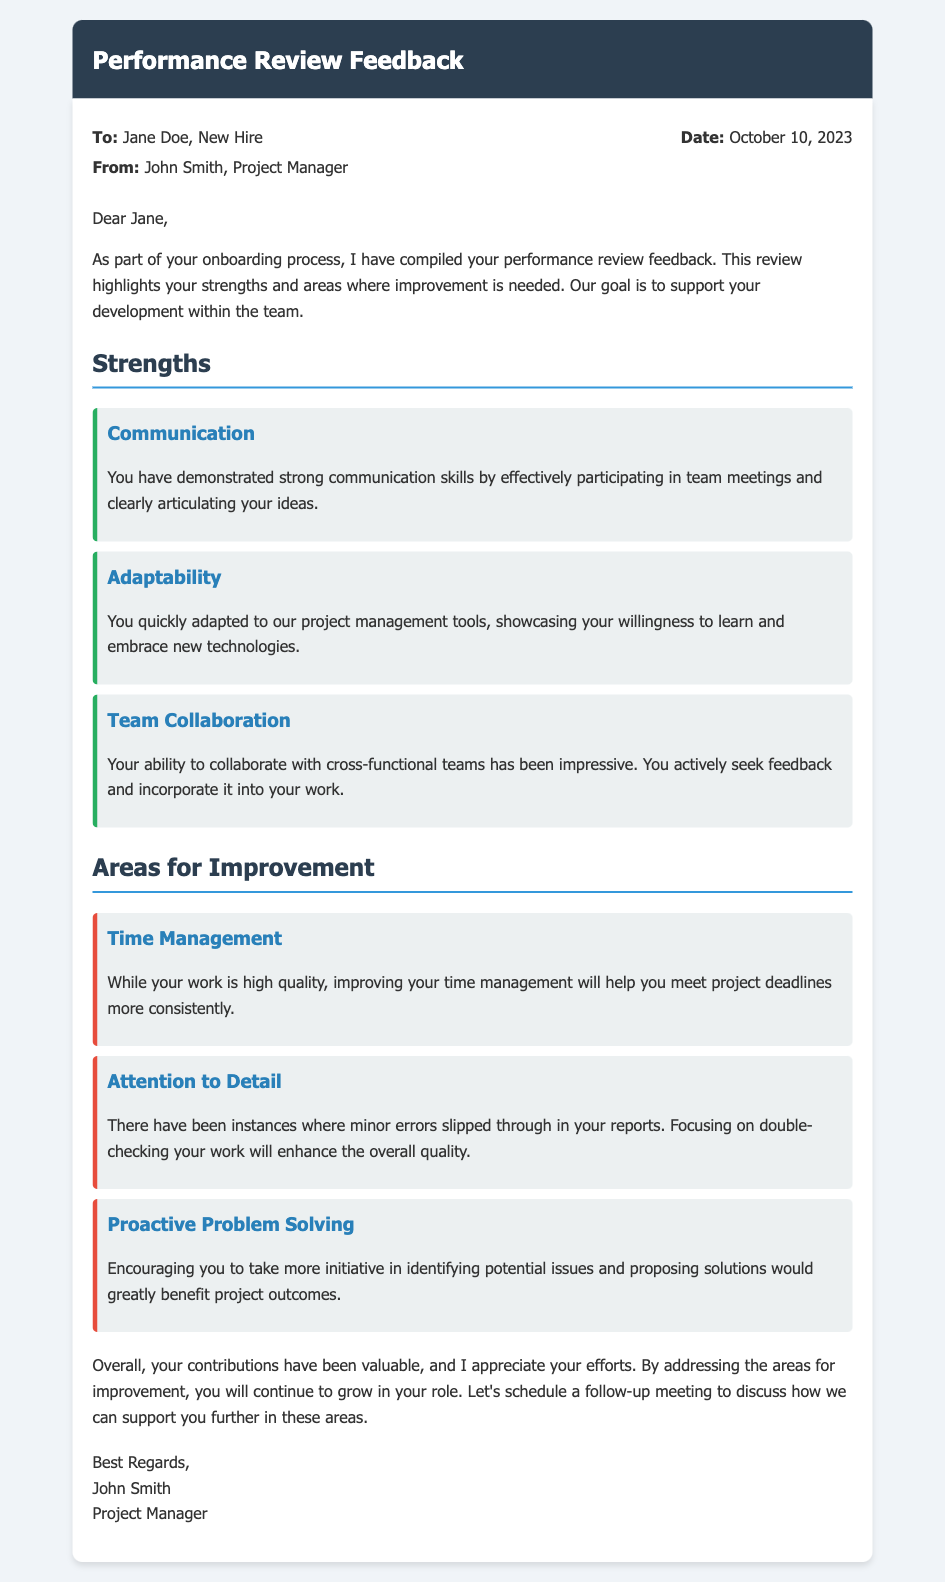what is the name of the new hire? The new hire is mentioned in the recipient section of the memo.
Answer: Jane Doe who authored the performance review memo? The author of the memo is stated at the beginning of the document.
Answer: John Smith what date was the performance review feedback generated? The date is provided in the memo details section.
Answer: October 10, 2023 what strength is highlighted related to collaboration? This refers to a specific strength discussed in the document under strengths.
Answer: Team Collaboration what is one area for improvement mentioned? This is found in the section discussing areas for improvement.
Answer: Time Management how many strengths are listed in the memo? This can be counted from the strengths section of the memo.
Answer: Three which skill is mentioned under areas for improvement that requires double-checking work? The focus is on skills that may need more attention, as indicated in the memo.
Answer: Attention to Detail how does the author propose to support the new hire in areas for improvement? This is discussed in the conclusion of the memo.
Answer: Schedule a follow-up meeting 